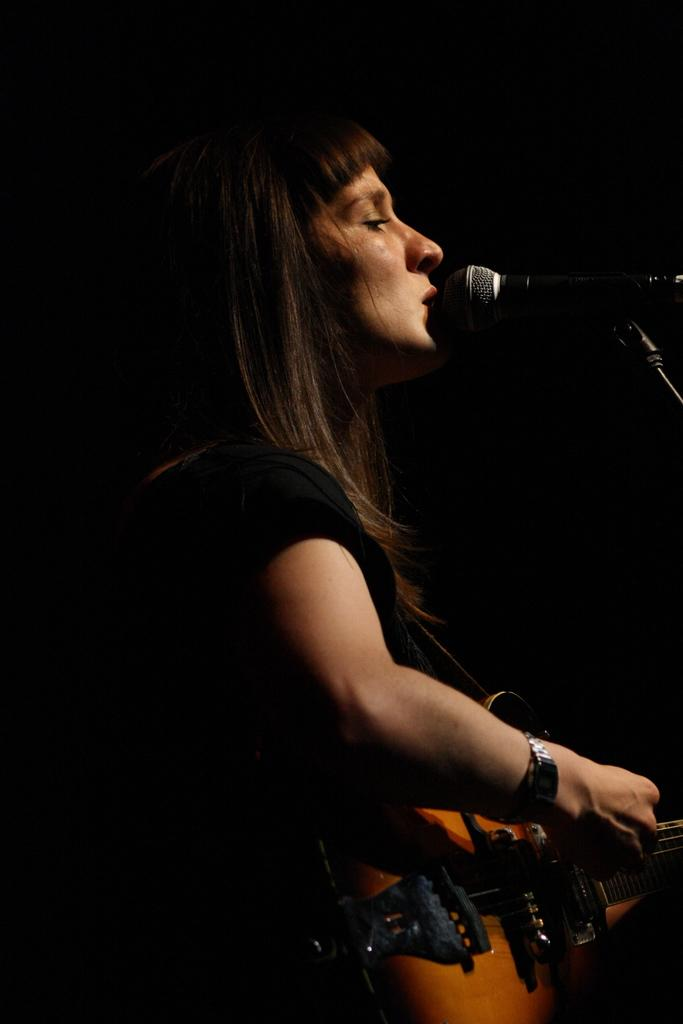What is the main subject of the image? The main subject of the image is a woman. What is the woman wearing in the image? The woman is wearing a black t-shirt in the image. What object is the woman holding in the image? The woman is holding a guitar in the image. What is the woman doing with the guitar? The woman is playing the guitar in the image. What device is in front of the woman? There is a microphone in front of the woman in the image. What is the woman doing with the microphone? The woman is singing on the microphone in the image. How many pizzas are being served in the image? There are no pizzas present in the image; it features a woman playing a guitar and singing on a microphone. What type of show is the woman performing in the image? There is no indication of a show or performance in the image; it simply shows a woman playing a guitar and singing on a microphone. 